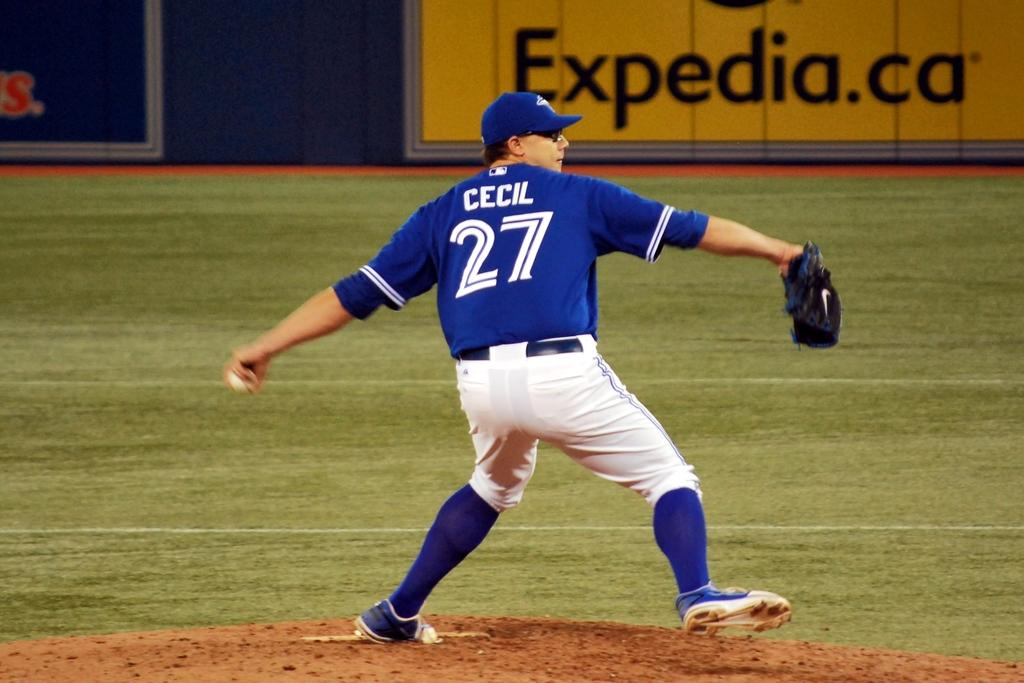<image>
Provide a brief description of the given image. Player number 27 has his arm back and ready to throw the ball. 